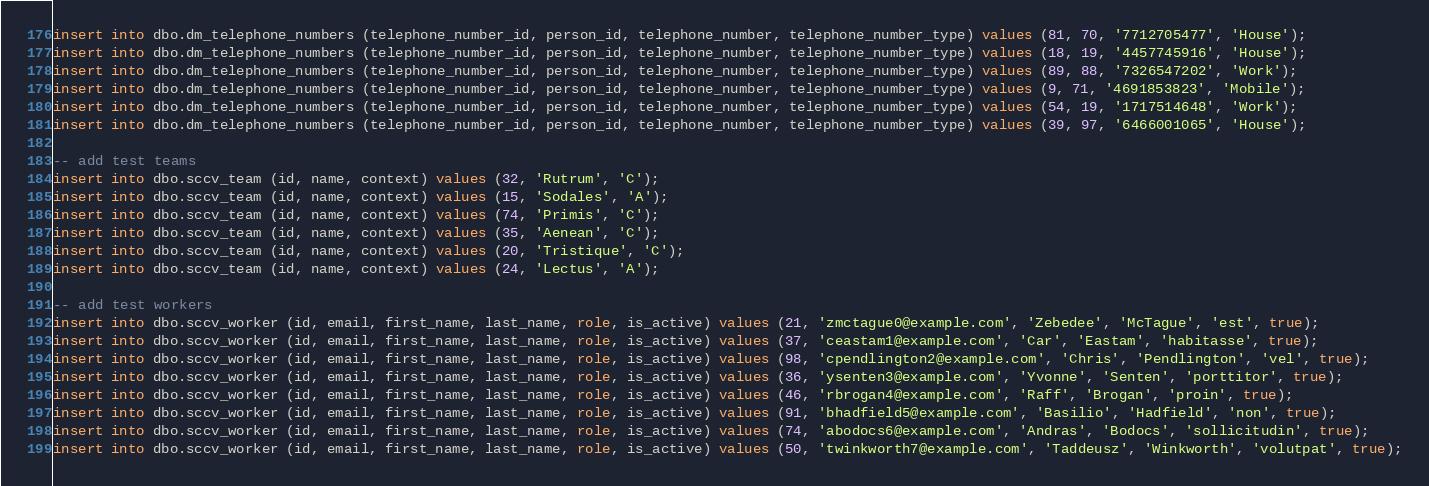Convert code to text. <code><loc_0><loc_0><loc_500><loc_500><_SQL_>insert into dbo.dm_telephone_numbers (telephone_number_id, person_id, telephone_number, telephone_number_type) values (81, 70, '7712705477', 'House');
insert into dbo.dm_telephone_numbers (telephone_number_id, person_id, telephone_number, telephone_number_type) values (18, 19, '4457745916', 'House');
insert into dbo.dm_telephone_numbers (telephone_number_id, person_id, telephone_number, telephone_number_type) values (89, 88, '7326547202', 'Work');
insert into dbo.dm_telephone_numbers (telephone_number_id, person_id, telephone_number, telephone_number_type) values (9, 71, '4691853823', 'Mobile');
insert into dbo.dm_telephone_numbers (telephone_number_id, person_id, telephone_number, telephone_number_type) values (54, 19, '1717514648', 'Work');
insert into dbo.dm_telephone_numbers (telephone_number_id, person_id, telephone_number, telephone_number_type) values (39, 97, '6466001065', 'House');

-- add test teams
insert into dbo.sccv_team (id, name, context) values (32, 'Rutrum', 'C');
insert into dbo.sccv_team (id, name, context) values (15, 'Sodales', 'A');
insert into dbo.sccv_team (id, name, context) values (74, 'Primis', 'C');
insert into dbo.sccv_team (id, name, context) values (35, 'Aenean', 'C');
insert into dbo.sccv_team (id, name, context) values (20, 'Tristique', 'C');
insert into dbo.sccv_team (id, name, context) values (24, 'Lectus', 'A');

-- add test workers
insert into dbo.sccv_worker (id, email, first_name, last_name, role, is_active) values (21, 'zmctague0@example.com', 'Zebedee', 'McTague', 'est', true);
insert into dbo.sccv_worker (id, email, first_name, last_name, role, is_active) values (37, 'ceastam1@example.com', 'Car', 'Eastam', 'habitasse', true);
insert into dbo.sccv_worker (id, email, first_name, last_name, role, is_active) values (98, 'cpendlington2@example.com', 'Chris', 'Pendlington', 'vel', true);
insert into dbo.sccv_worker (id, email, first_name, last_name, role, is_active) values (36, 'ysenten3@example.com', 'Yvonne', 'Senten', 'porttitor', true);
insert into dbo.sccv_worker (id, email, first_name, last_name, role, is_active) values (46, 'rbrogan4@example.com', 'Raff', 'Brogan', 'proin', true);
insert into dbo.sccv_worker (id, email, first_name, last_name, role, is_active) values (91, 'bhadfield5@example.com', 'Basilio', 'Hadfield', 'non', true);
insert into dbo.sccv_worker (id, email, first_name, last_name, role, is_active) values (74, 'abodocs6@example.com', 'Andras', 'Bodocs', 'sollicitudin', true);
insert into dbo.sccv_worker (id, email, first_name, last_name, role, is_active) values (50, 'twinkworth7@example.com', 'Taddeusz', 'Winkworth', 'volutpat', true);</code> 